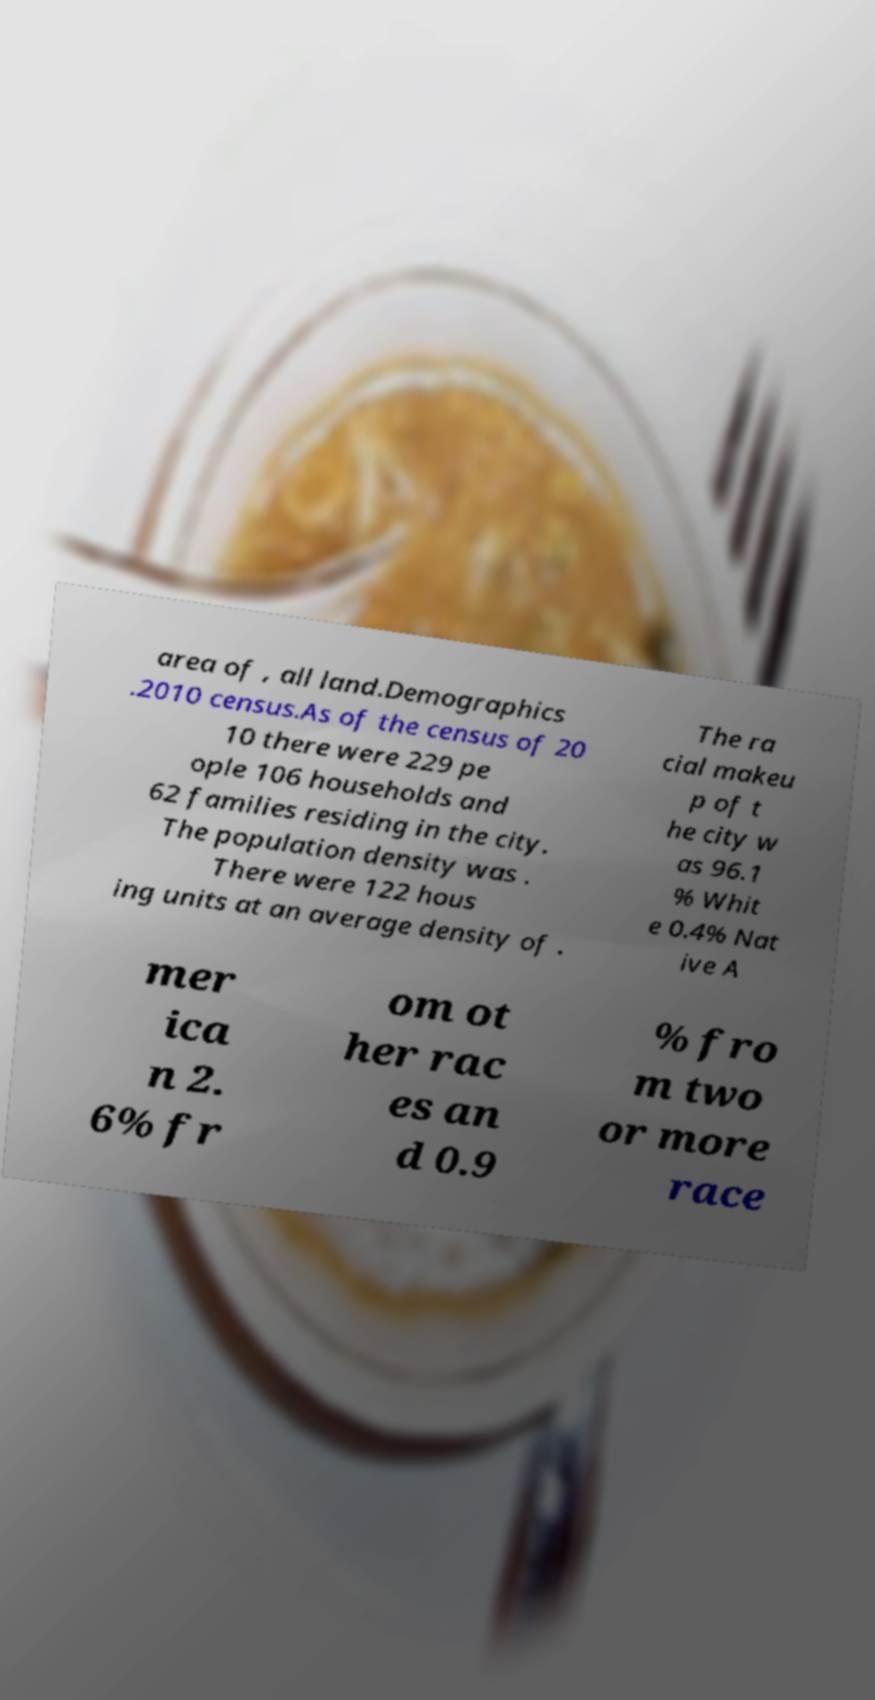Please read and relay the text visible in this image. What does it say? area of , all land.Demographics .2010 census.As of the census of 20 10 there were 229 pe ople 106 households and 62 families residing in the city. The population density was . There were 122 hous ing units at an average density of . The ra cial makeu p of t he city w as 96.1 % Whit e 0.4% Nat ive A mer ica n 2. 6% fr om ot her rac es an d 0.9 % fro m two or more race 